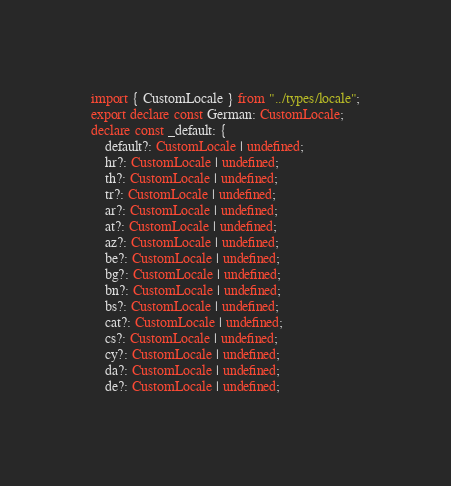<code> <loc_0><loc_0><loc_500><loc_500><_TypeScript_>import { CustomLocale } from "../types/locale";
export declare const German: CustomLocale;
declare const _default: {
    default?: CustomLocale | undefined;
    hr?: CustomLocale | undefined;
    th?: CustomLocale | undefined;
    tr?: CustomLocale | undefined;
    ar?: CustomLocale | undefined;
    at?: CustomLocale | undefined;
    az?: CustomLocale | undefined;
    be?: CustomLocale | undefined;
    bg?: CustomLocale | undefined;
    bn?: CustomLocale | undefined;
    bs?: CustomLocale | undefined;
    cat?: CustomLocale | undefined;
    cs?: CustomLocale | undefined;
    cy?: CustomLocale | undefined;
    da?: CustomLocale | undefined;
    de?: CustomLocale | undefined;</code> 